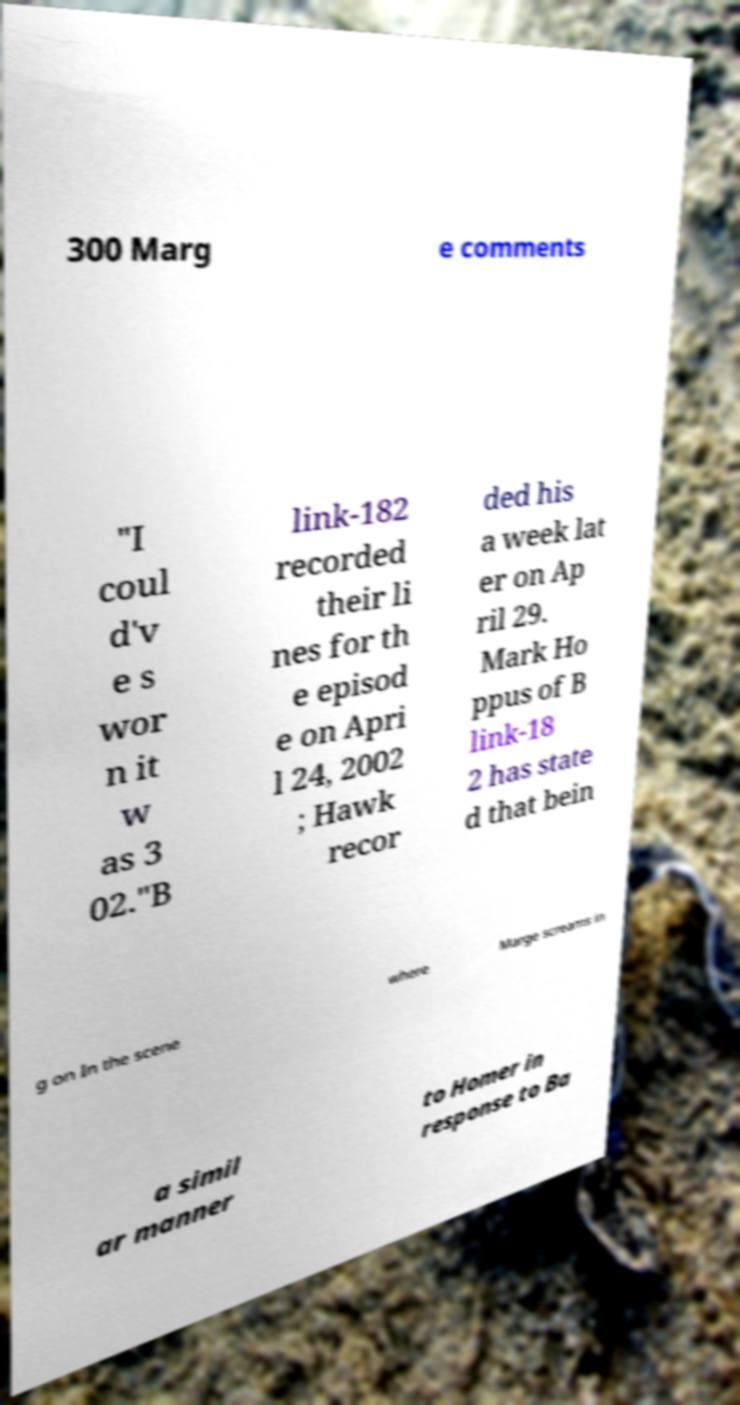I need the written content from this picture converted into text. Can you do that? 300 Marg e comments "I coul d'v e s wor n it w as 3 02."B link-182 recorded their li nes for th e episod e on Apri l 24, 2002 ; Hawk recor ded his a week lat er on Ap ril 29. Mark Ho ppus of B link-18 2 has state d that bein g on In the scene where Marge screams in a simil ar manner to Homer in response to Ba 